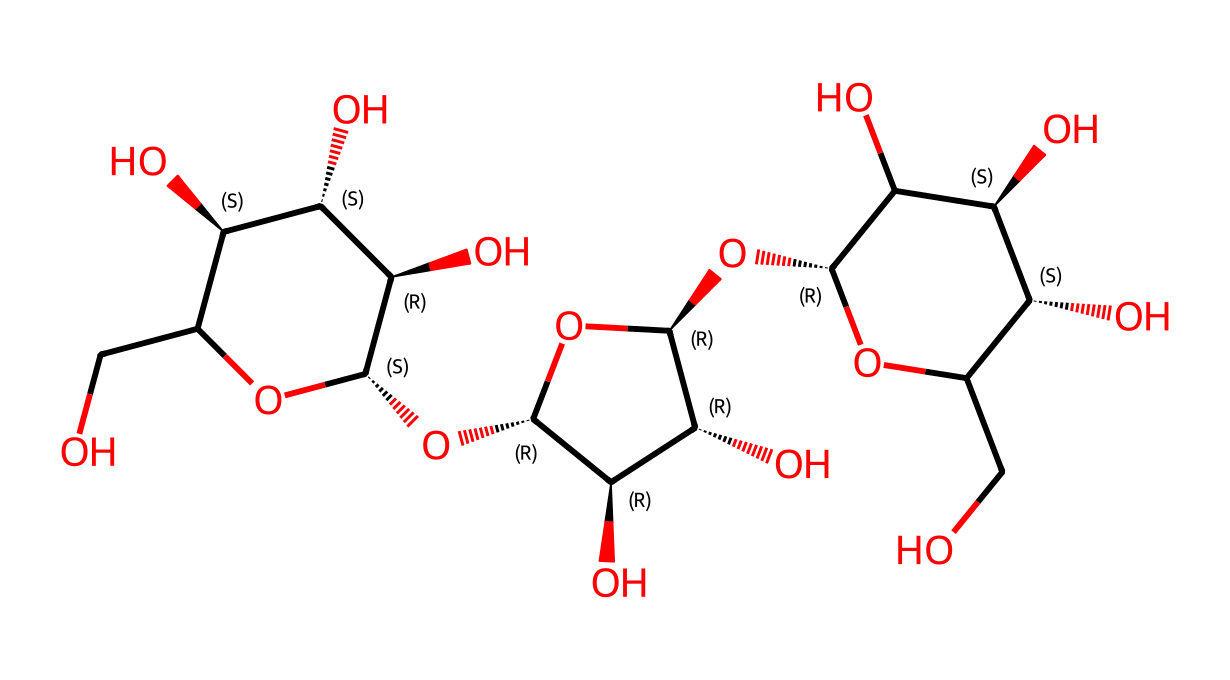What is the elemental composition of cellulose? Cellulose is primarily composed of carbon, hydrogen, and oxygen atoms. By analyzing the SMILES representation, we can identify the respective atoms present and their ratios.
Answer: carbon, hydrogen, oxygen How many rings are present in the cellulose structure? The SMILES representation shows the presence of a multi-cyclic framework. By counting the 'C' atoms connected in a cyclic manner, we can conclude there are three distinct ring structures in cellulose.
Answer: three What type of carbohydrate is cellulose? Cellulose is classified as a polysaccharide because it consists of long chains of monosaccharides (glucose units) bonded together. This is derived from the repeating units visible in the SMILES structure.
Answer: polysaccharide What is the number of hydroxyl (–OH) groups in cellulose? The structure of cellulose includes multiple hydroxyl groups that can be counted directly from the SMILES representation. By following the 'O' atoms connected to 'H', we see there are six hydroxyl groups in total.
Answer: six What is the main role of cellulose in fabrics? The primary role of cellulose in fabrics like cotton is to provide strength and structural integrity, which is inferred from its fibrous nature as a polymer that contributes to the texture and durability of textiles.
Answer: strength How does the presence of glucose units influence the properties of cellulose? The arrangement of glucose units (specifically their glycosidic linkages) influences the rigidity and insolubility of cellulose, making it resistant to enzymatic digestion, as indicated by the structural features in the SMILES notation that depict these units.
Answer: rigidity, insolubility 